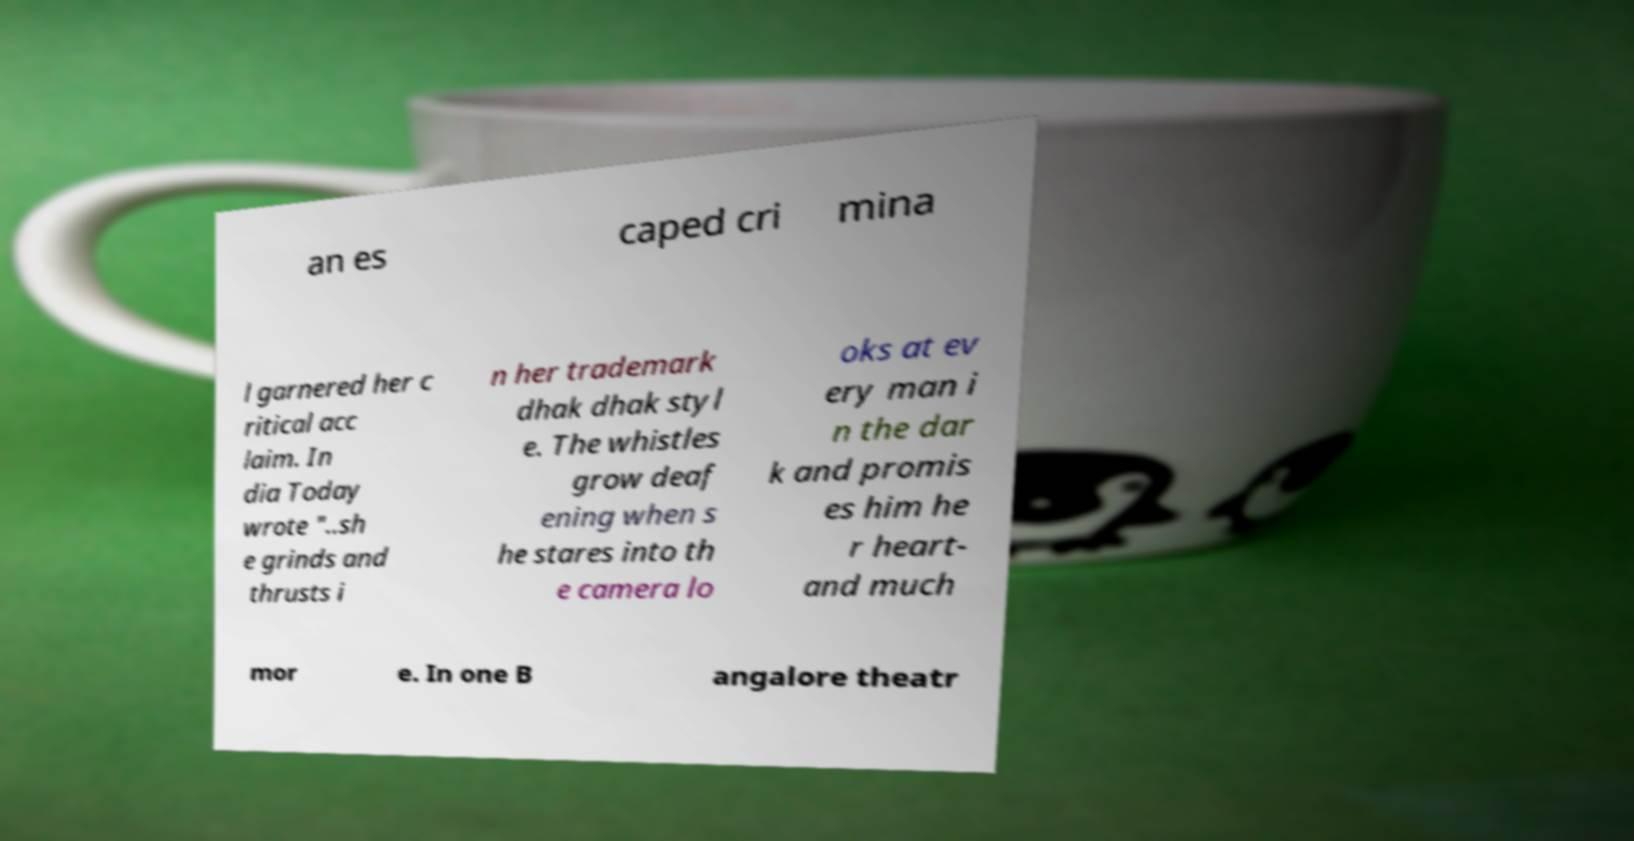What messages or text are displayed in this image? I need them in a readable, typed format. an es caped cri mina l garnered her c ritical acc laim. In dia Today wrote "..sh e grinds and thrusts i n her trademark dhak dhak styl e. The whistles grow deaf ening when s he stares into th e camera lo oks at ev ery man i n the dar k and promis es him he r heart- and much mor e. In one B angalore theatr 